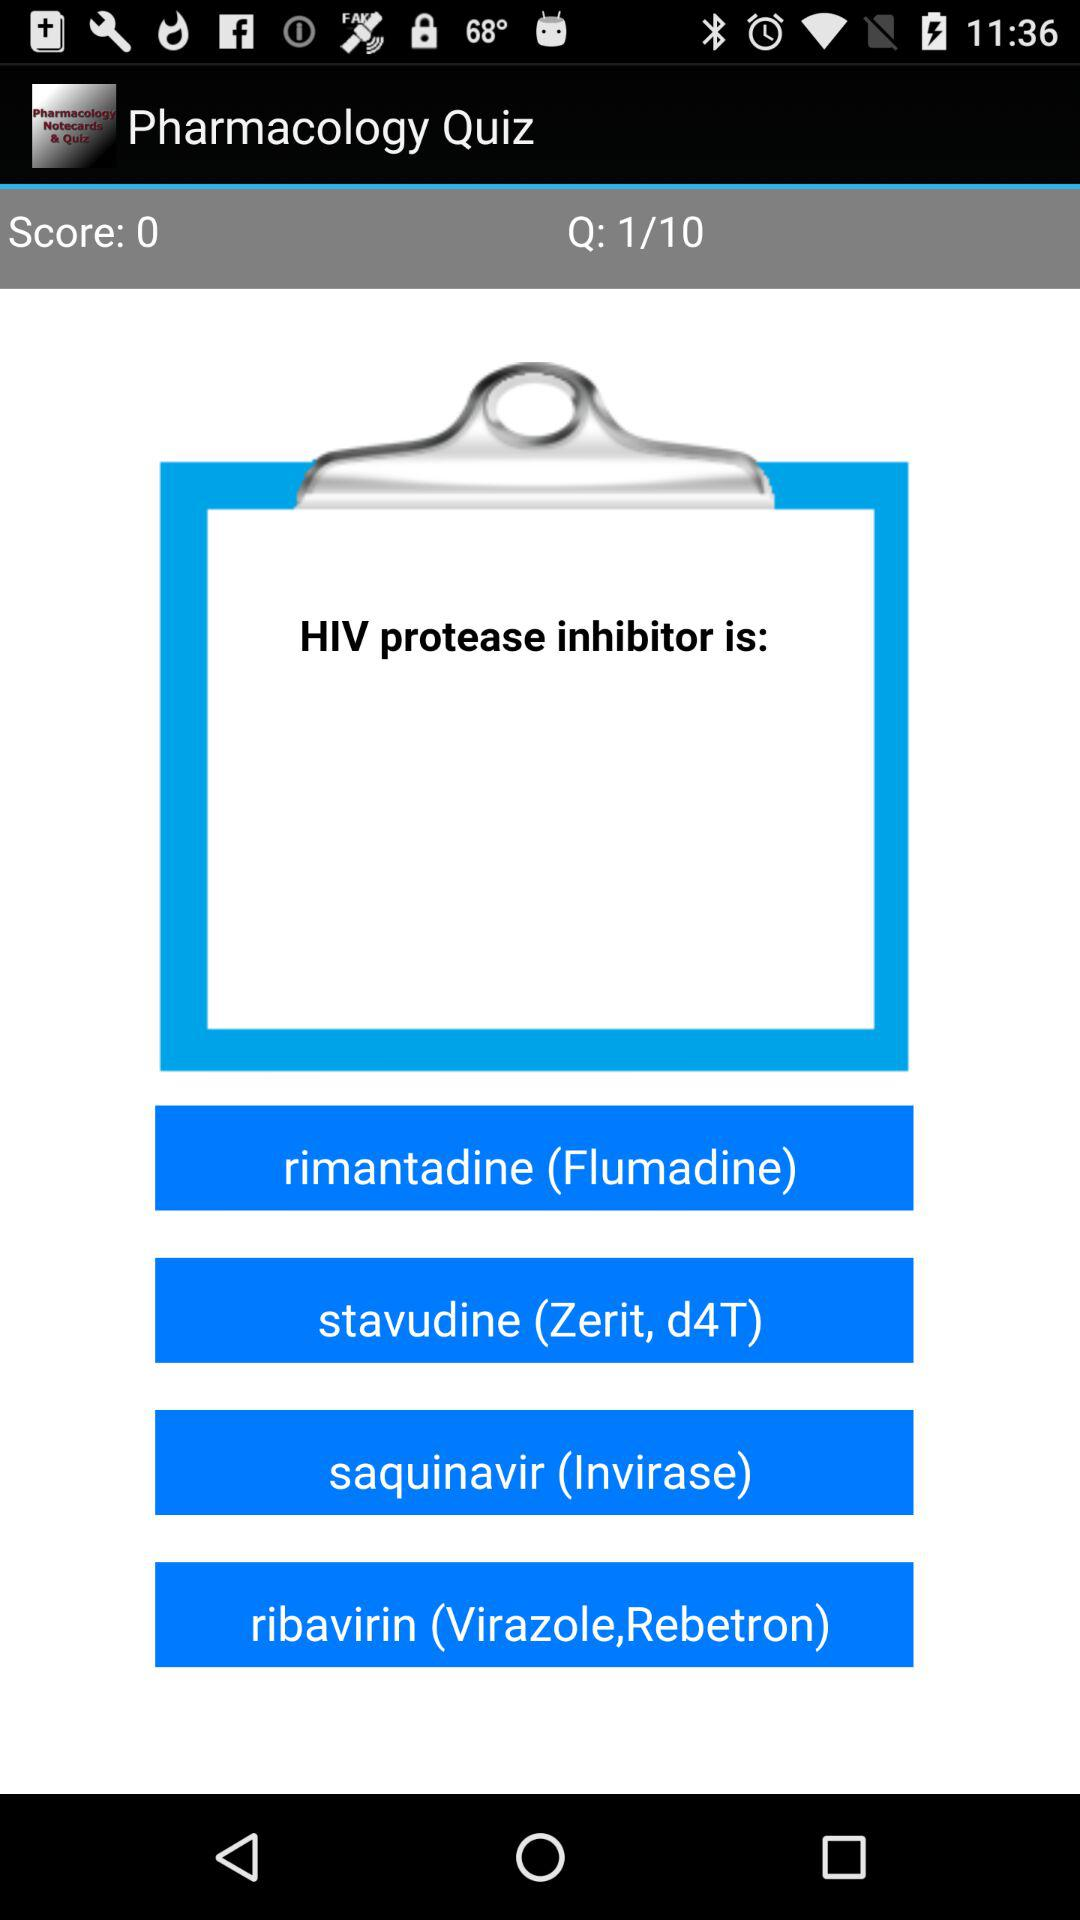How many answer choices are there for the question?
Answer the question using a single word or phrase. 4 